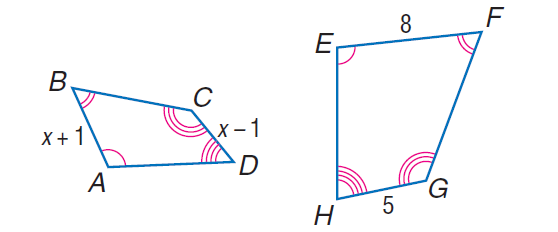Answer the mathemtical geometry problem and directly provide the correct option letter.
Question: Each pair of polygons is similar. Find A B.
Choices: A: 1.6 B: \frac { 16 } { 3 } C: 6 D: 10 B 